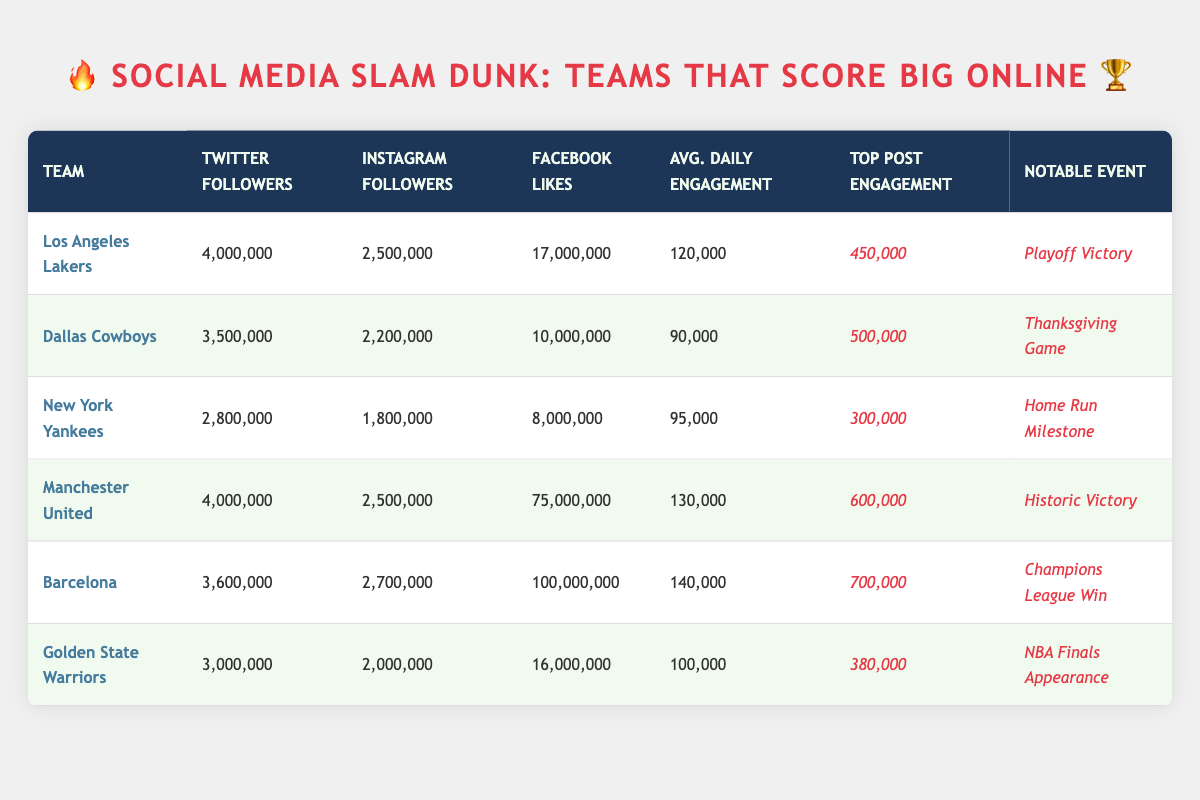What team has the highest number of Facebook likes? According to the table, Barcelona has 100,000,000 Facebook likes. It's the highest value compared to all the other teams listed.
Answer: Barcelona Which team had the highest top post engagement? In the data, Barcelona again takes the lead with a top post engagement of 700,000, which surpasses all other teams' numbers.
Answer: Barcelona Calculate the total average daily engagement of all teams. The total average daily engagement is calculated by summing the daily engagement: (120,000 + 90,000 + 95,000 + 130,000 + 140,000 + 100,000) = 675,000. Since there are 6 teams, the average is 675,000 / 6 = 112,500.
Answer: 112,500 Is Manchester United’s average daily engagement higher than the Los Angeles Lakers’? Manchester United has an average daily engagement of 130,000, while the Lakers have 120,000. Thus, yes, Manchester United's engagement is higher.
Answer: Yes What is the difference in Twitter followers between the Dallas Cowboys and the Golden State Warriors? The Dallas Cowboys have 3,500,000 Twitter followers, and the Golden State Warriors have 3,000,000. The difference is 3,500,000 - 3,000,000 = 500,000.
Answer: 500,000 Which team has more Instagram followers, the New York Yankees or the Golden State Warriors? The New York Yankees have 1,800,000 Instagram followers, while the Golden State Warriors have 2,000,000. Thus, the Warriors have more followers.
Answer: Golden State Warriors What is the average number of followers across all social media platforms for the Los Angeles Lakers? The average can be calculated by adding the followers from all platforms: (4,000,000 + 2,500,000 + 17,000,000) = 23,500,000. Then, dividing by the number of platforms, 3, the average is 23,500,000 / 3 = 7,833,333.33.
Answer: 7,833,333.33 Which team had a notable event related to a playoff win? From the table, the Los Angeles Lakers are noted for their 'Playoff Victory.' This is mentioned in the notable event column specifically for them.
Answer: Los Angeles Lakers How many teams have an average daily engagement above 100,000? In the table, four teams have an average daily engagement above 100,000: Los Angeles Lakers (120,000), Manchester United (130,000), Barcelona (140,000), and Golden State Warriors (100,000). Thus, there are four teams meeting this criterion.
Answer: 4 Is it true that the New York Yankees have more total social media followers than the Dallas Cowboys? The New York Yankees: 2,800,000 (Twitter) + 1,800,000 (Instagram) + 8,000,000 (Facebook) = 12,600,000 total followers. The Dallas Cowboys have 3,500,000 (Twitter) + 2,200,000 (Instagram) + 10,000,000 (Facebook) = 15,700,000. Therefore, this statement is false.
Answer: No 